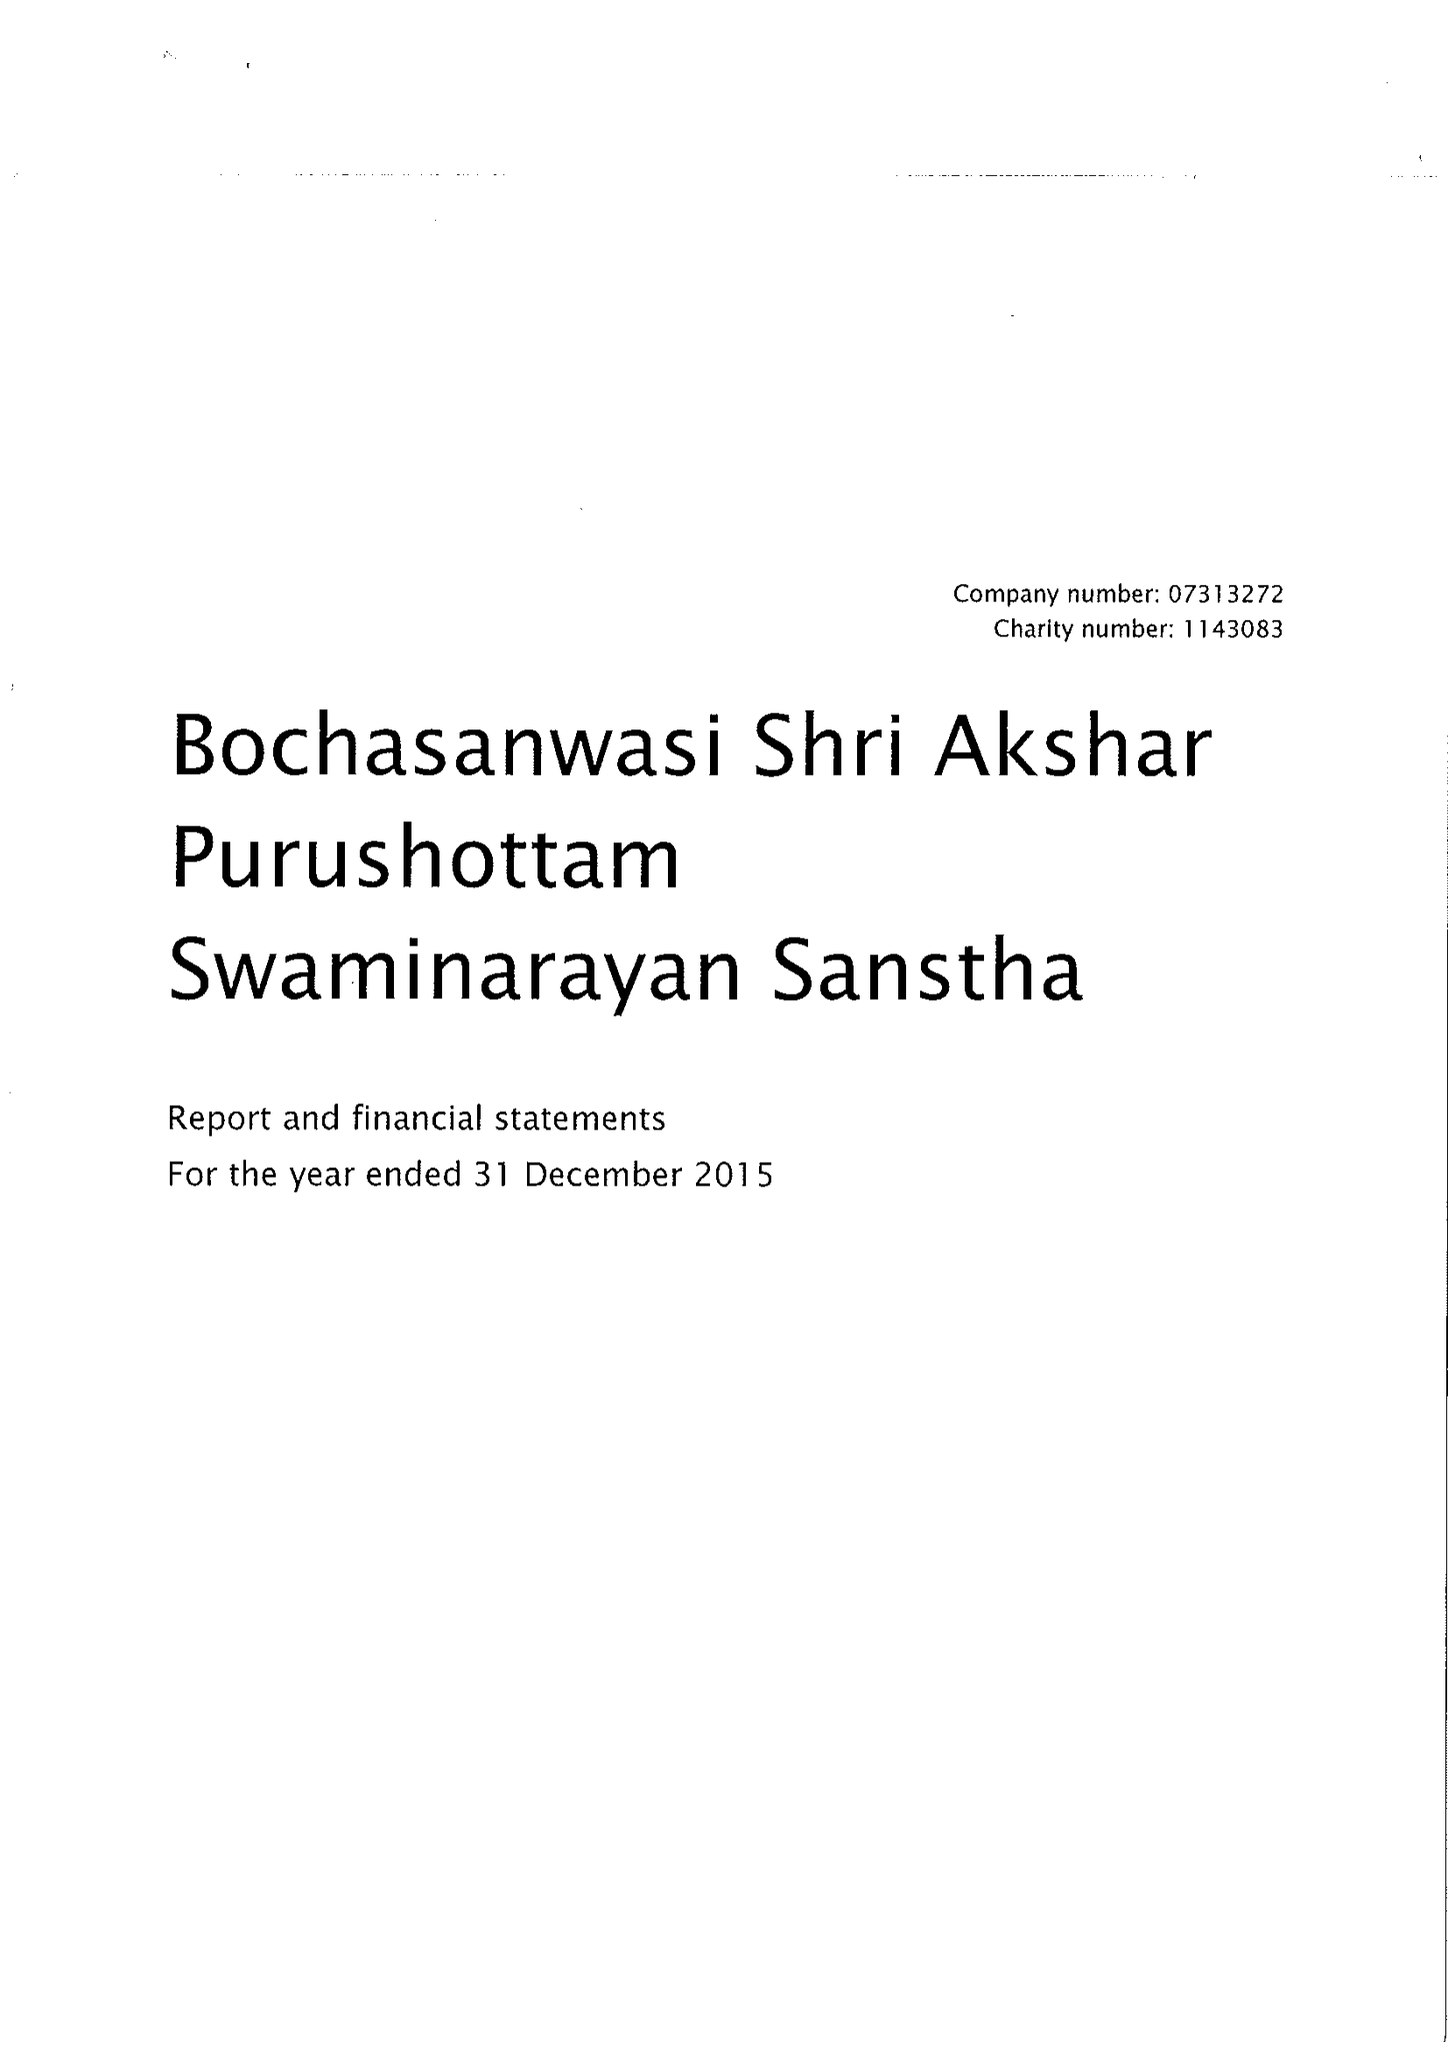What is the value for the report_date?
Answer the question using a single word or phrase. 2015-12-31 